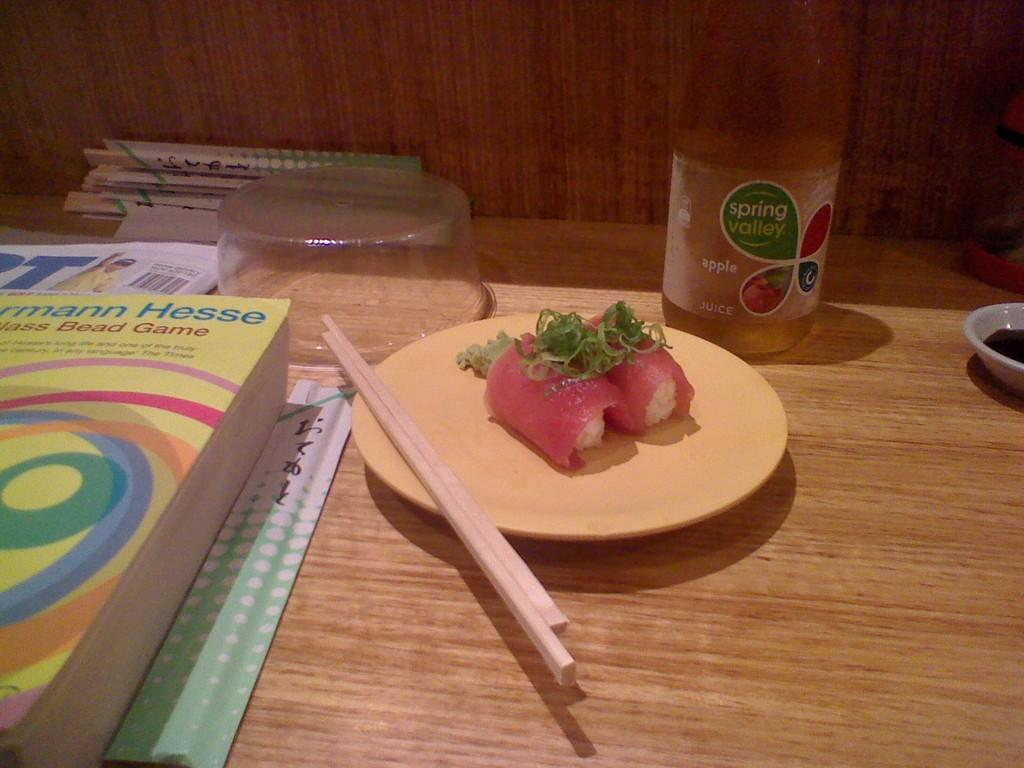<image>
Summarize the visual content of the image. a bottle of spring valley apple juice behind a plate of food 